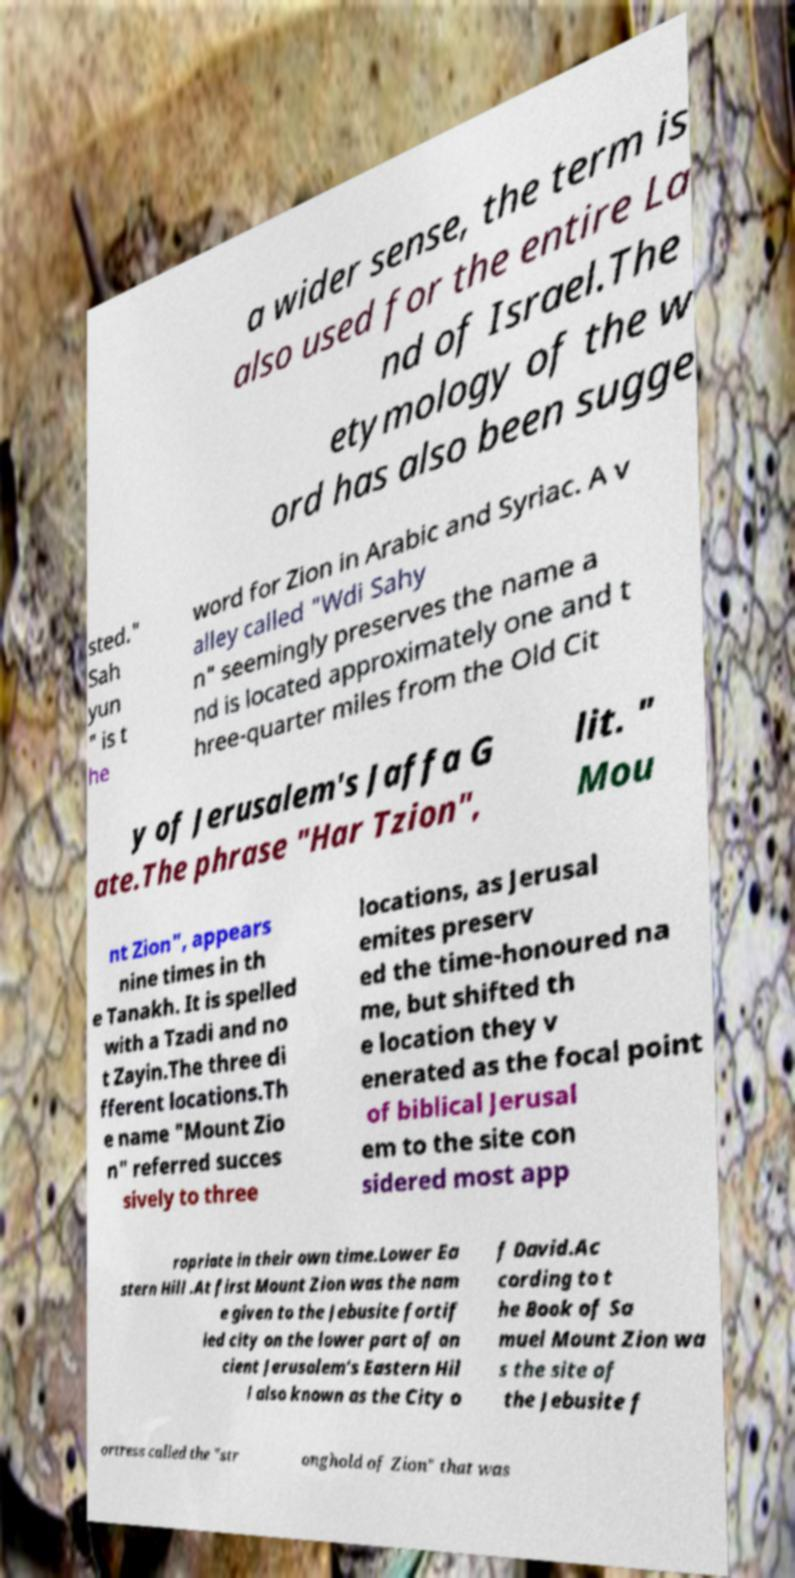Could you assist in decoding the text presented in this image and type it out clearly? a wider sense, the term is also used for the entire La nd of Israel.The etymology of the w ord has also been sugge sted." Sah yun " is t he word for Zion in Arabic and Syriac. A v alley called "Wdi Sahy n" seemingly preserves the name a nd is located approximately one and t hree-quarter miles from the Old Cit y of Jerusalem's Jaffa G ate.The phrase "Har Tzion", lit. " Mou nt Zion", appears nine times in th e Tanakh. It is spelled with a Tzadi and no t Zayin.The three di fferent locations.Th e name "Mount Zio n" referred succes sively to three locations, as Jerusal emites preserv ed the time-honoured na me, but shifted th e location they v enerated as the focal point of biblical Jerusal em to the site con sidered most app ropriate in their own time.Lower Ea stern Hill .At first Mount Zion was the nam e given to the Jebusite fortif ied city on the lower part of an cient Jerusalem's Eastern Hil l also known as the City o f David.Ac cording to t he Book of Sa muel Mount Zion wa s the site of the Jebusite f ortress called the "str onghold of Zion" that was 